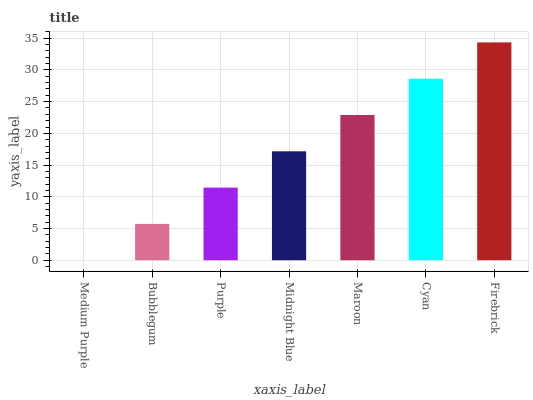Is Medium Purple the minimum?
Answer yes or no. Yes. Is Firebrick the maximum?
Answer yes or no. Yes. Is Bubblegum the minimum?
Answer yes or no. No. Is Bubblegum the maximum?
Answer yes or no. No. Is Bubblegum greater than Medium Purple?
Answer yes or no. Yes. Is Medium Purple less than Bubblegum?
Answer yes or no. Yes. Is Medium Purple greater than Bubblegum?
Answer yes or no. No. Is Bubblegum less than Medium Purple?
Answer yes or no. No. Is Midnight Blue the high median?
Answer yes or no. Yes. Is Midnight Blue the low median?
Answer yes or no. Yes. Is Cyan the high median?
Answer yes or no. No. Is Maroon the low median?
Answer yes or no. No. 